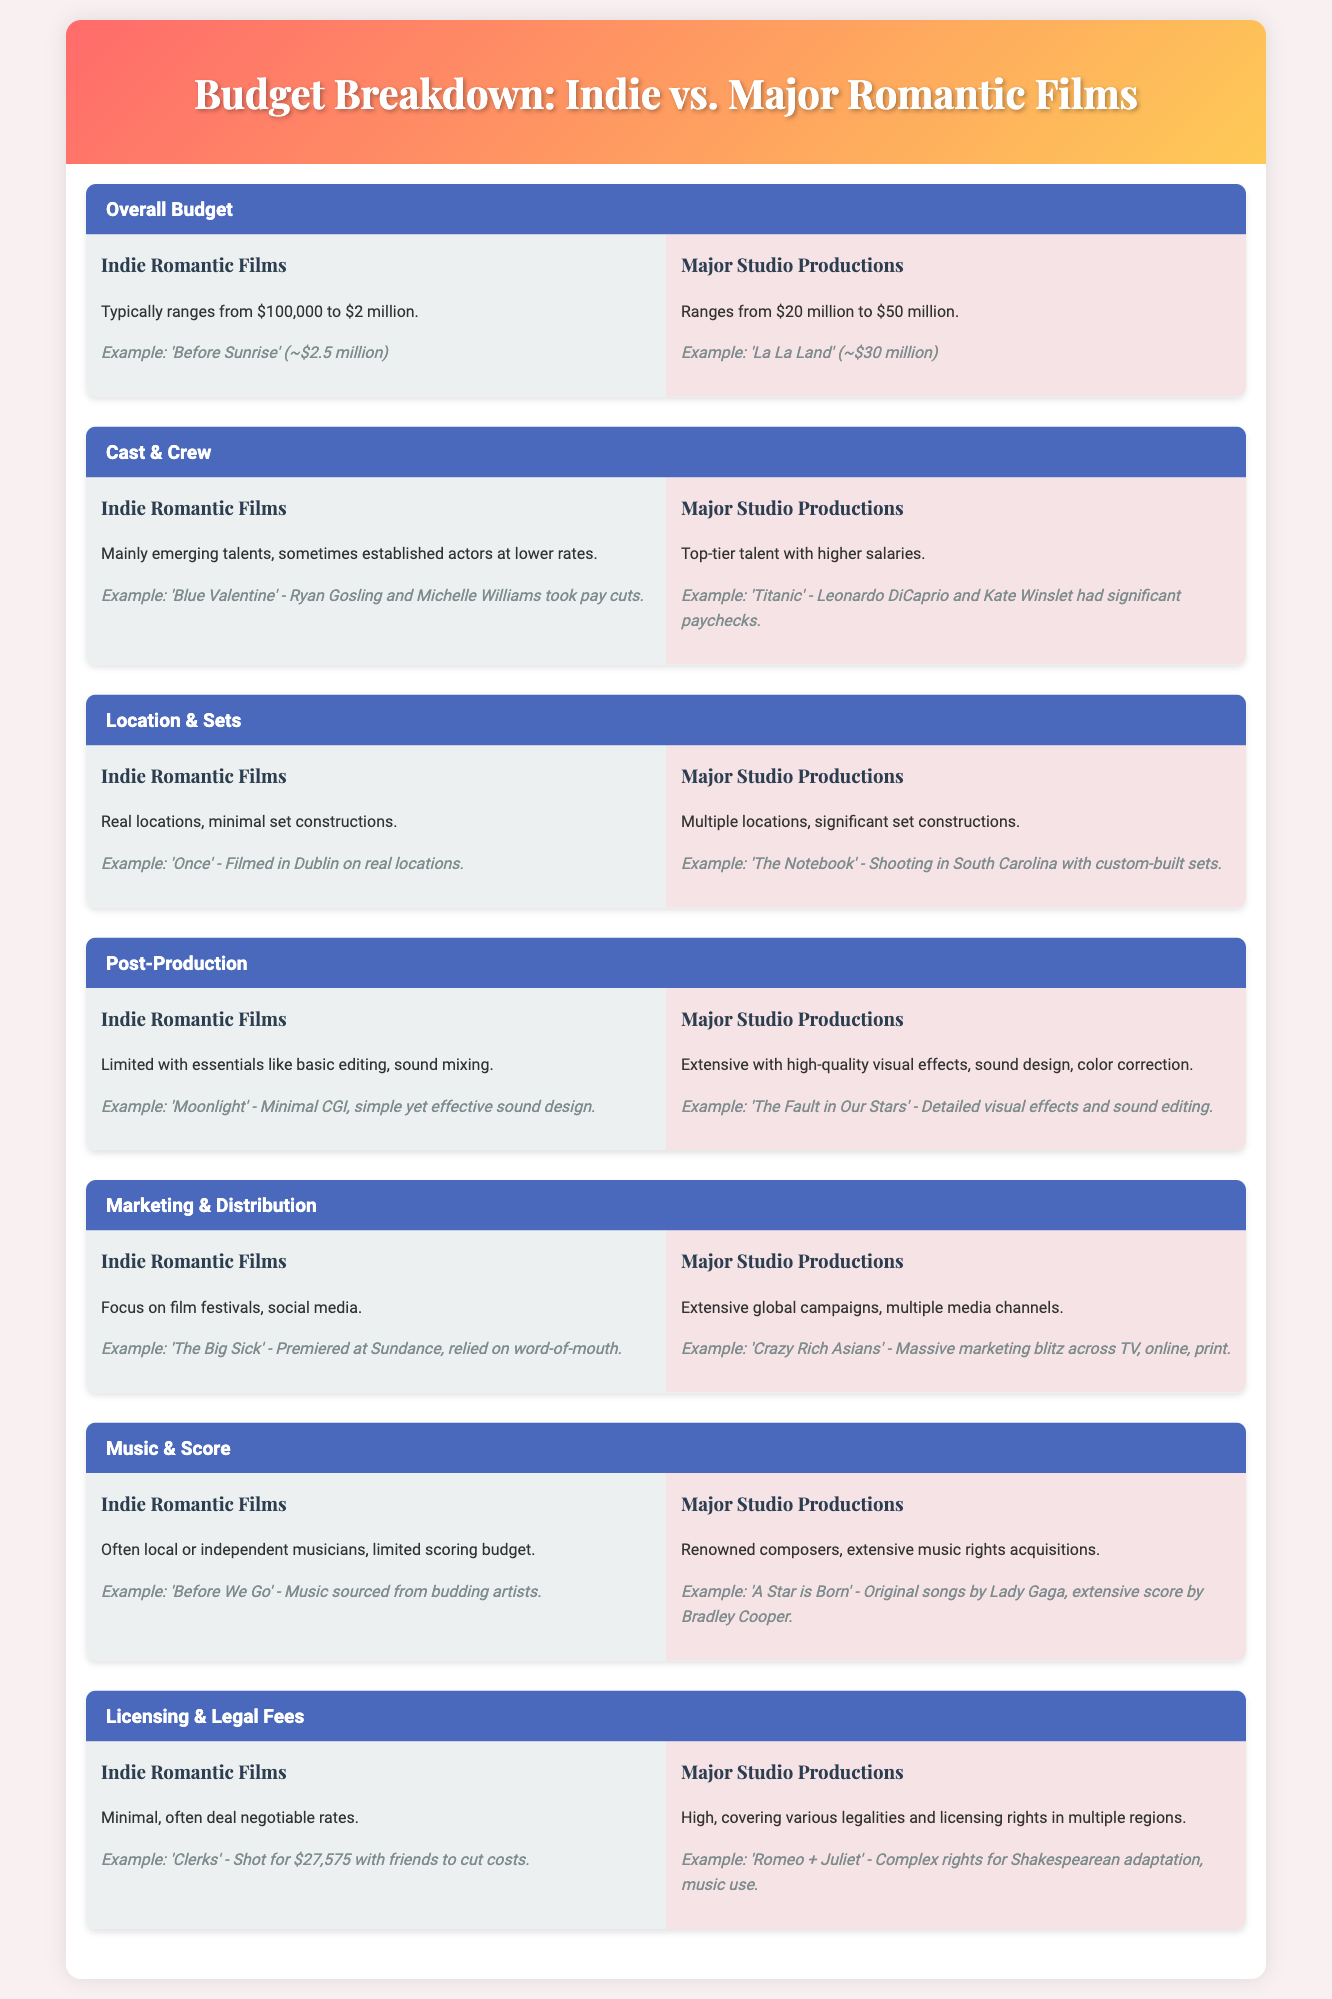What is the budget range for Indie Romantic Films? The budget range for Indie Romantic Films is provided in the document as typically from $100,000 to $2 million.
Answer: $100,000 to $2 million What is the budget range for Major Studio Productions? The document states that Major Studio Productions range from $20 million to $50 million.
Answer: $20 million to $50 million Who took pay cuts in 'Blue Valentine'? The document mentions that Ryan Gosling and Michelle Williams took pay cuts in the film 'Blue Valentine'.
Answer: Ryan Gosling and Michelle Williams What type of locations do Indie Romantic Films typically use? The document indicates that Indie Romantic Films mainly use real locations with minimal set constructions.
Answer: Real locations What type of talent is typically found in Major Studio Productions? The document states that Major Studio Productions usually feature top-tier talent with higher salaries.
Answer: Top-tier talent What example does the document give for a film with significant paychecks? The document cites 'Titanic' as having significant paychecks for its lead actors.
Answer: Titanic How do Indie Romantic Films primarily focus on marketing? According to the document, Indie Romantic Films focus on film festivals and social media for marketing.
Answer: Film festivals, social media What is the typical scoring budget for Indie Romantic Films? The document suggests that Indie Romantic Films often have a limited scoring budget with local musicians.
Answer: Limited scoring budget What notable example is provided for extensive marketing in Major Studio Productions? The example given is 'Crazy Rich Asians', which had a massive marketing blitz across various channels.
Answer: Crazy Rich Asians 